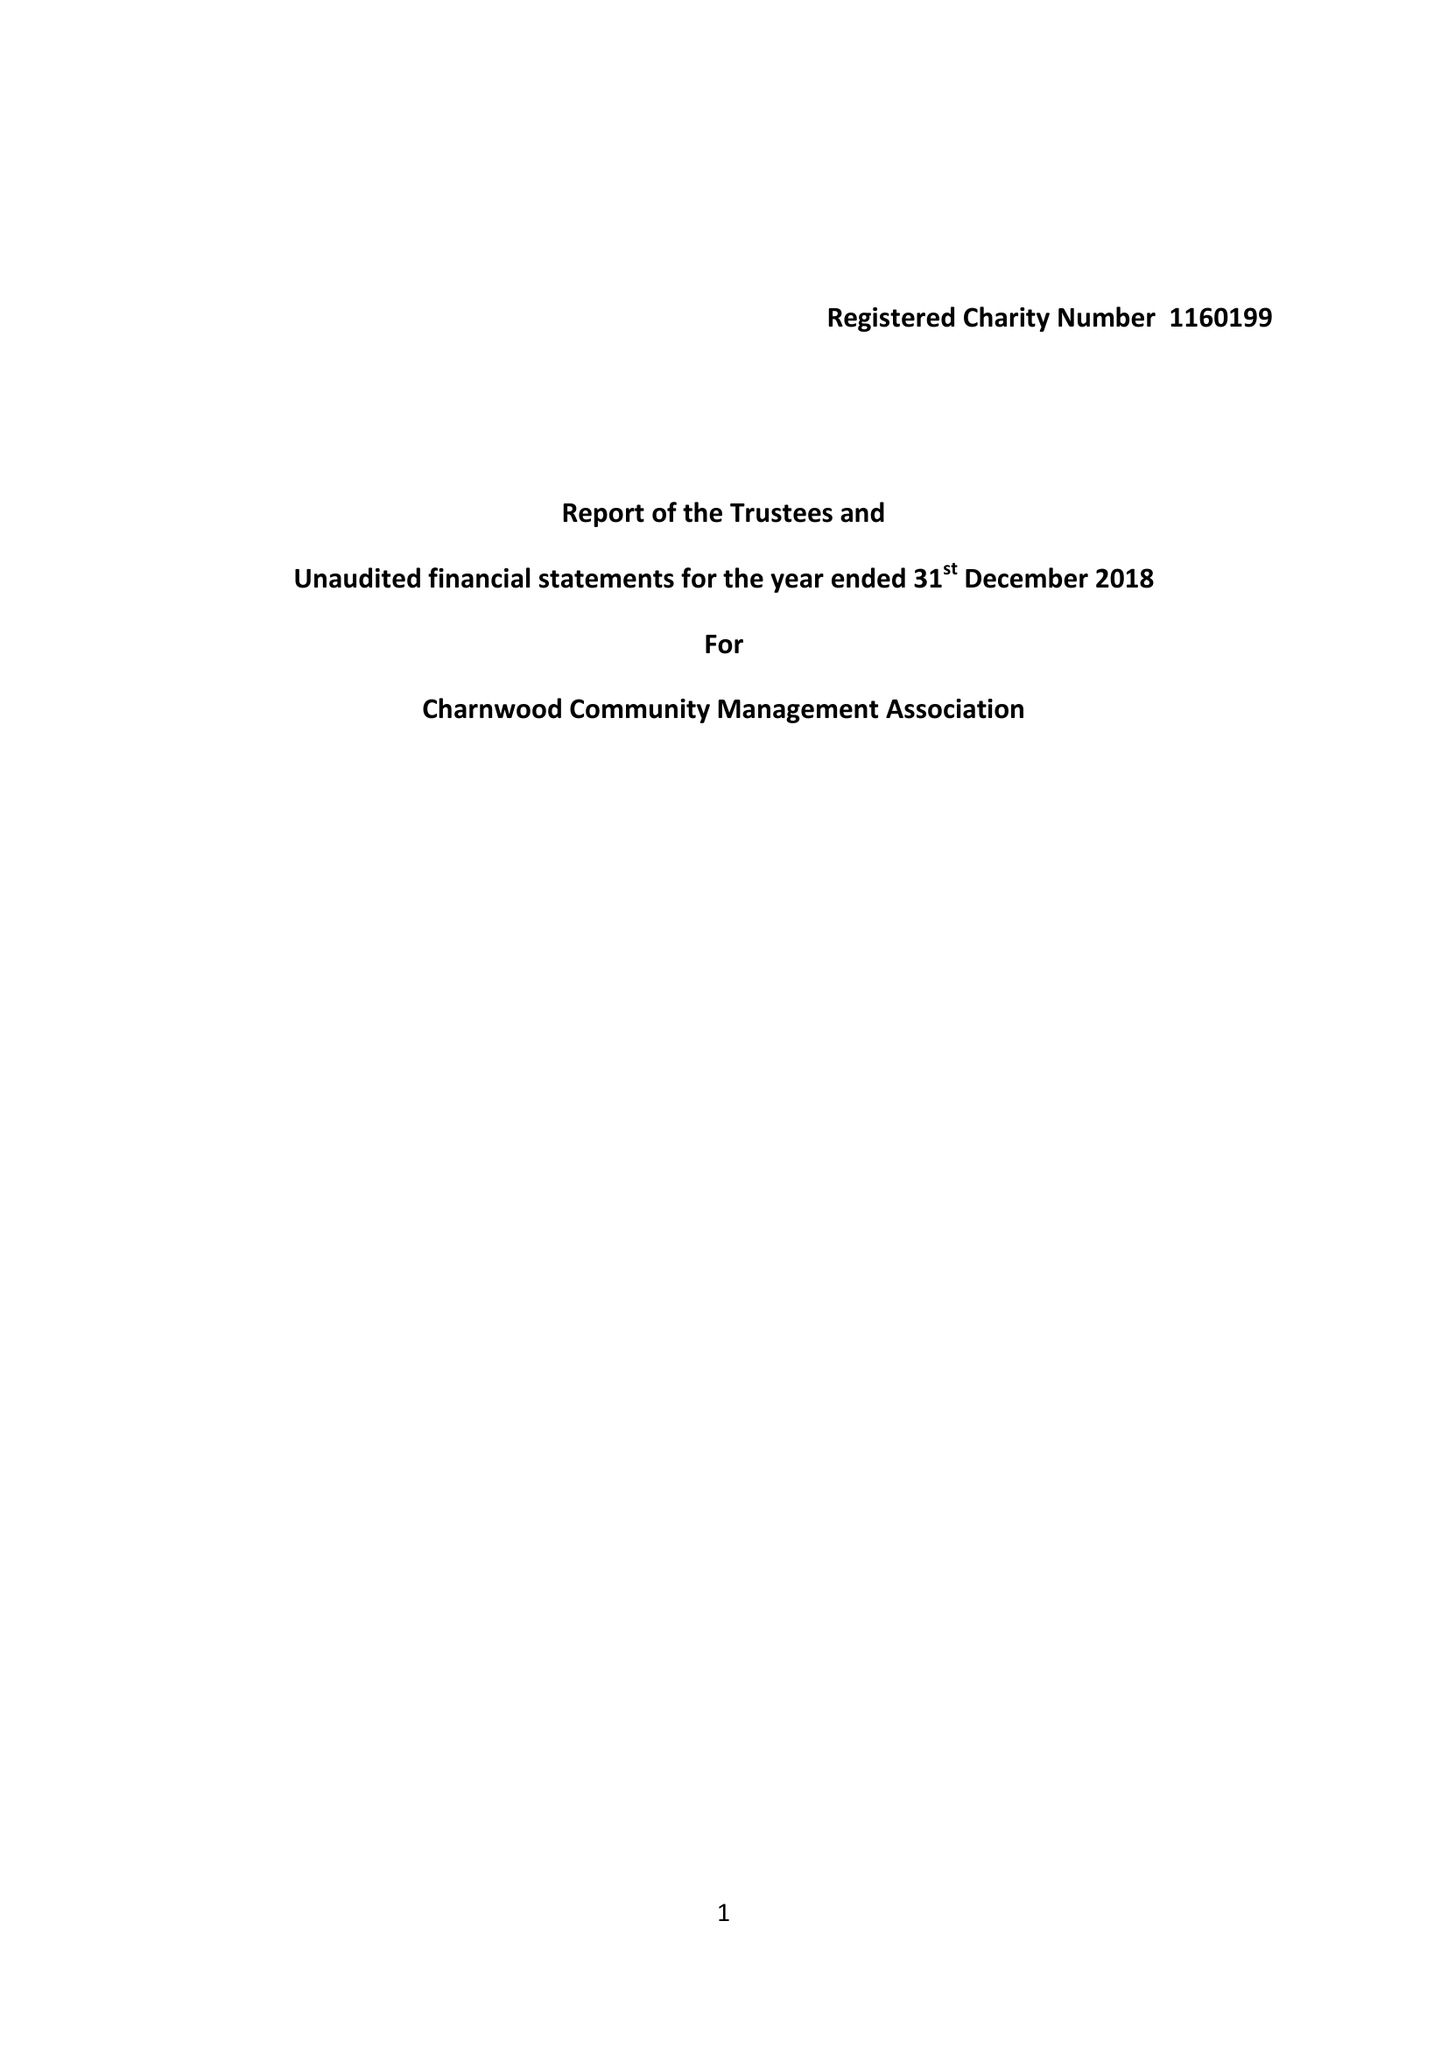What is the value for the charity_name?
Answer the question using a single word or phrase. Charnwood Community Management Association 